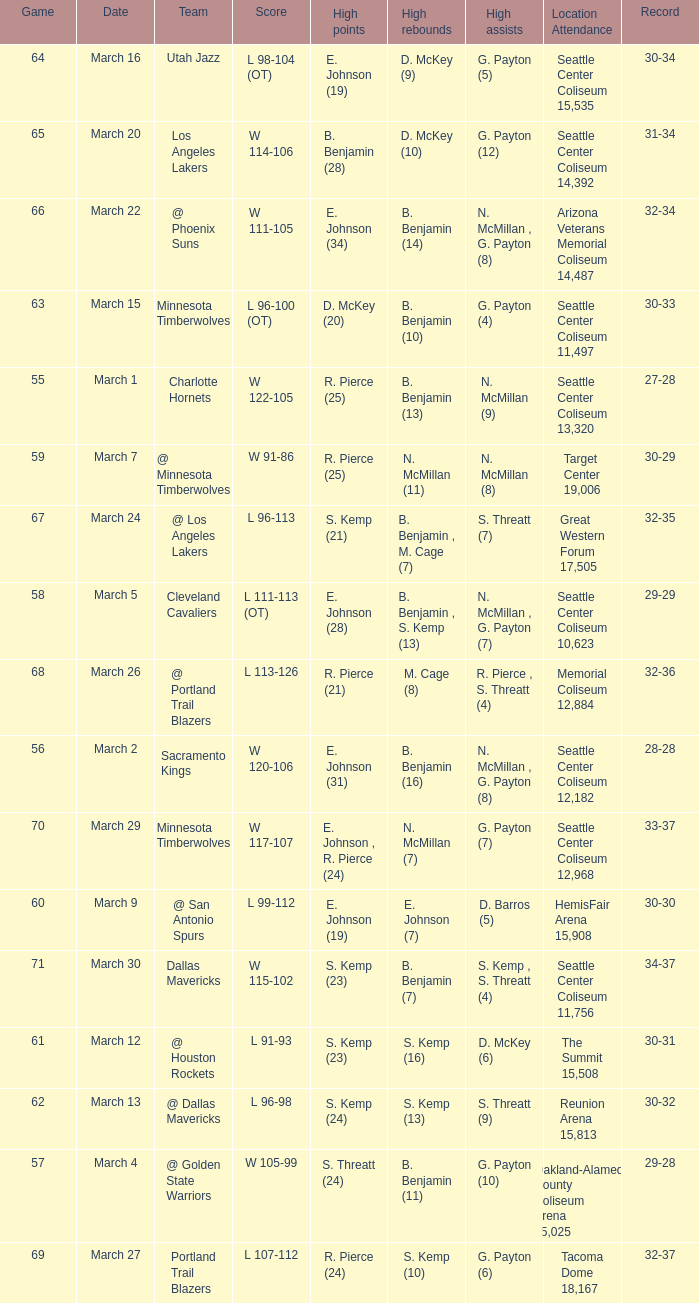WhichScore has a Location Attendance of seattle center coliseum 11,497? L 96-100 (OT). 